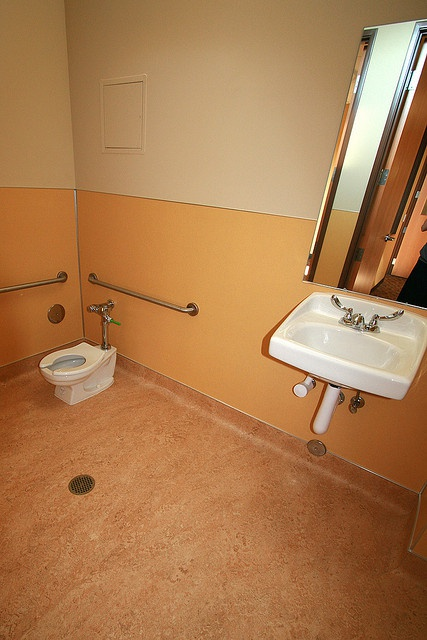Describe the objects in this image and their specific colors. I can see sink in olive, lightgray, tan, and darkgray tones and toilet in olive, tan, and gray tones in this image. 